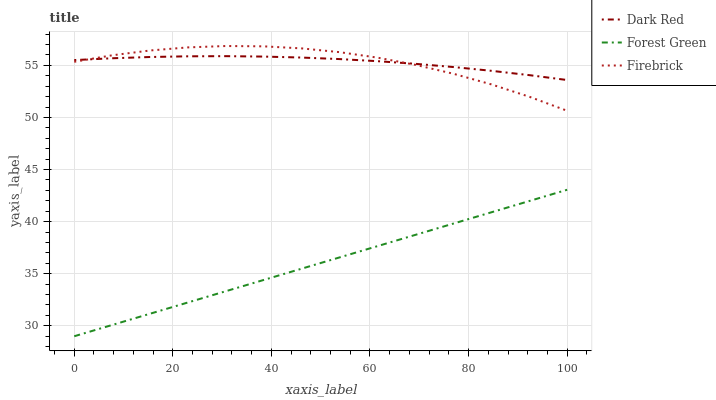Does Forest Green have the minimum area under the curve?
Answer yes or no. Yes. Does Dark Red have the maximum area under the curve?
Answer yes or no. Yes. Does Firebrick have the minimum area under the curve?
Answer yes or no. No. Does Firebrick have the maximum area under the curve?
Answer yes or no. No. Is Forest Green the smoothest?
Answer yes or no. Yes. Is Firebrick the roughest?
Answer yes or no. Yes. Is Firebrick the smoothest?
Answer yes or no. No. Is Forest Green the roughest?
Answer yes or no. No. Does Firebrick have the lowest value?
Answer yes or no. No. Does Forest Green have the highest value?
Answer yes or no. No. Is Forest Green less than Firebrick?
Answer yes or no. Yes. Is Firebrick greater than Forest Green?
Answer yes or no. Yes. Does Forest Green intersect Firebrick?
Answer yes or no. No. 